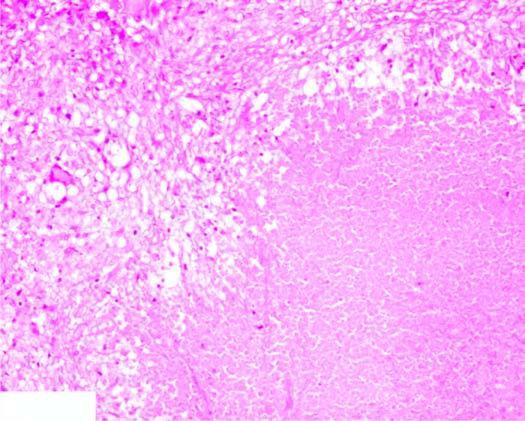what does the periphery show?
Answer the question using a single word or phrase. Granulomatous inflammation 